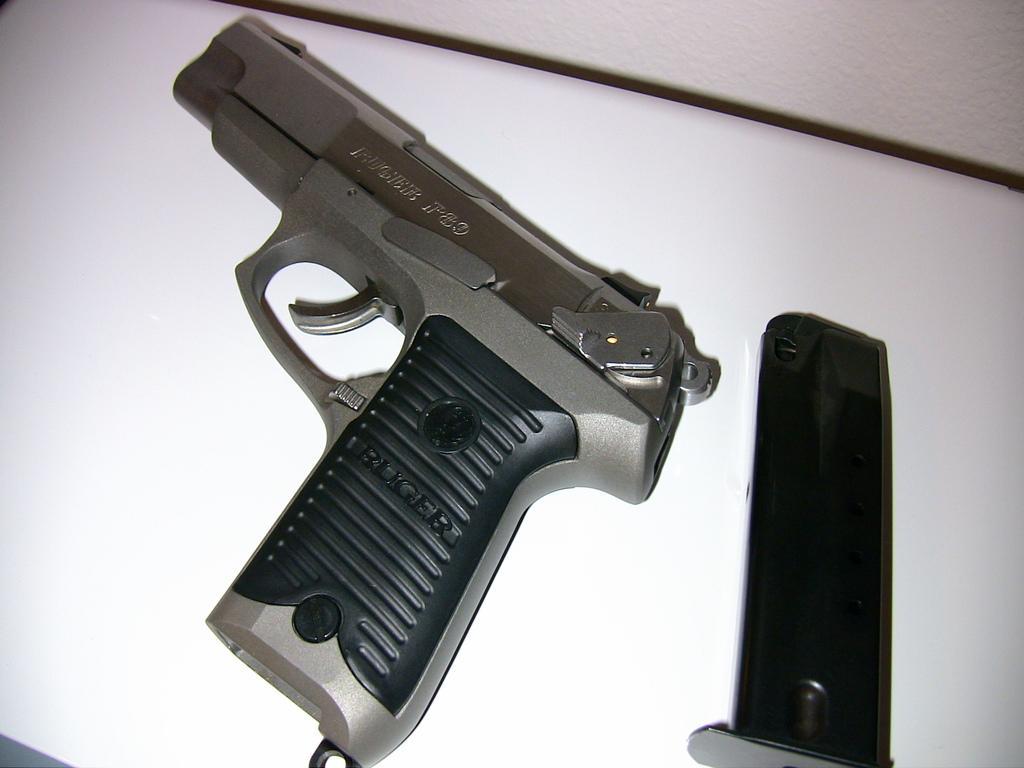Please provide a concise description of this image. In this image we can see a gun and magazine on an object on a platform. 